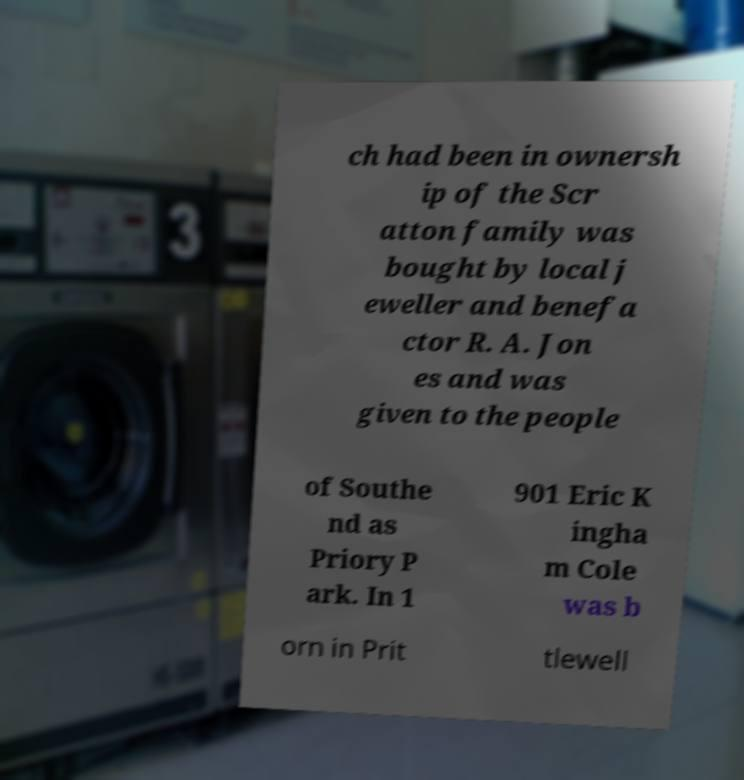For documentation purposes, I need the text within this image transcribed. Could you provide that? ch had been in ownersh ip of the Scr atton family was bought by local j eweller and benefa ctor R. A. Jon es and was given to the people of Southe nd as Priory P ark. In 1 901 Eric K ingha m Cole was b orn in Prit tlewell 